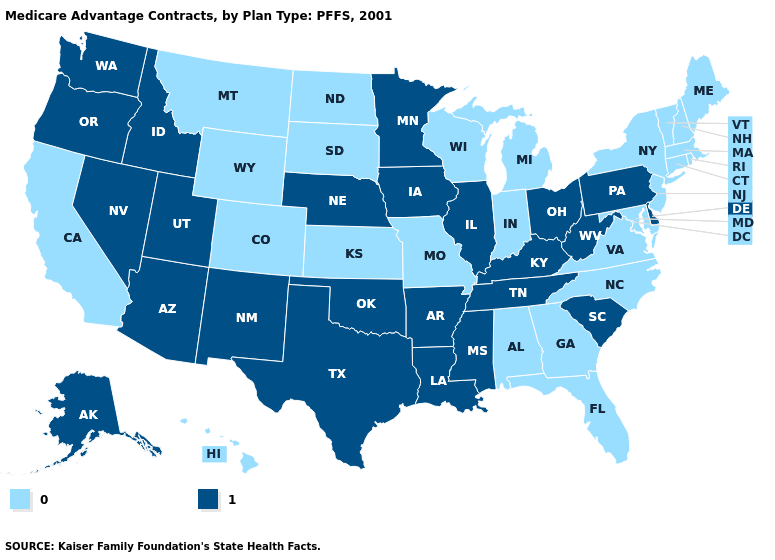Which states have the highest value in the USA?
Be succinct. Alaska, Arkansas, Arizona, Delaware, Iowa, Idaho, Illinois, Kentucky, Louisiana, Minnesota, Mississippi, Nebraska, New Mexico, Nevada, Ohio, Oklahoma, Oregon, Pennsylvania, South Carolina, Tennessee, Texas, Utah, Washington, West Virginia. Which states have the highest value in the USA?
Be succinct. Alaska, Arkansas, Arizona, Delaware, Iowa, Idaho, Illinois, Kentucky, Louisiana, Minnesota, Mississippi, Nebraska, New Mexico, Nevada, Ohio, Oklahoma, Oregon, Pennsylvania, South Carolina, Tennessee, Texas, Utah, Washington, West Virginia. Does Vermont have the lowest value in the USA?
Keep it brief. Yes. What is the lowest value in the South?
Short answer required. 0. Does Oklahoma have the lowest value in the South?
Answer briefly. No. Does the first symbol in the legend represent the smallest category?
Give a very brief answer. Yes. Does the map have missing data?
Concise answer only. No. How many symbols are there in the legend?
Be succinct. 2. What is the highest value in the USA?
Concise answer only. 1. Name the states that have a value in the range 1?
Concise answer only. Alaska, Arkansas, Arizona, Delaware, Iowa, Idaho, Illinois, Kentucky, Louisiana, Minnesota, Mississippi, Nebraska, New Mexico, Nevada, Ohio, Oklahoma, Oregon, Pennsylvania, South Carolina, Tennessee, Texas, Utah, Washington, West Virginia. Is the legend a continuous bar?
Give a very brief answer. No. What is the value of Nevada?
Concise answer only. 1. What is the value of Georgia?
Be succinct. 0. Name the states that have a value in the range 0?
Be succinct. Alabama, California, Colorado, Connecticut, Florida, Georgia, Hawaii, Indiana, Kansas, Massachusetts, Maryland, Maine, Michigan, Missouri, Montana, North Carolina, North Dakota, New Hampshire, New Jersey, New York, Rhode Island, South Dakota, Virginia, Vermont, Wisconsin, Wyoming. 